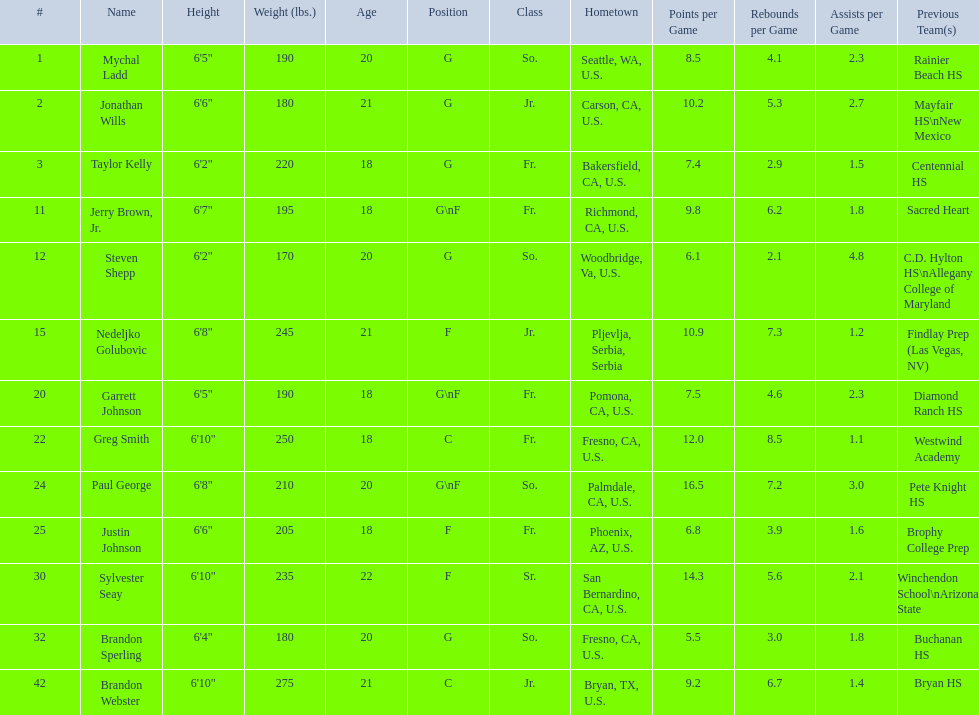Who is the only player not from the u. s.? Nedeljko Golubovic. 